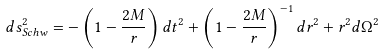<formula> <loc_0><loc_0><loc_500><loc_500>d s ^ { 2 } _ { S c h w } = - \left ( 1 - \frac { 2 M } r \right ) d t ^ { 2 } + \left ( 1 - \frac { 2 M } r \right ) ^ { - 1 } d r ^ { 2 } + r ^ { 2 } d \Omega ^ { 2 } \,</formula> 